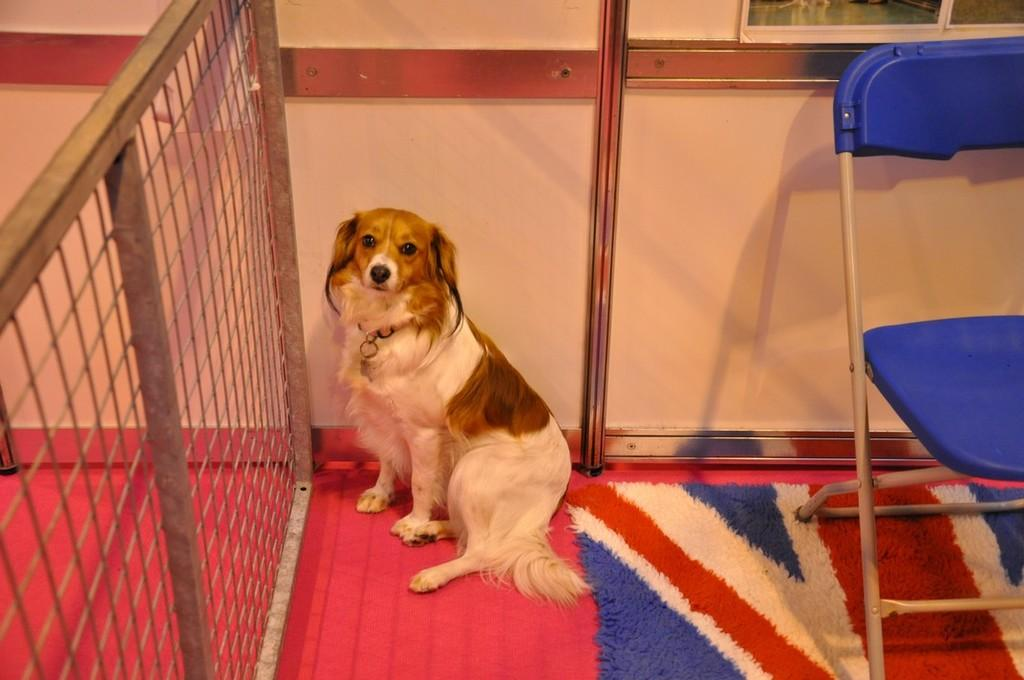What animal is present in the image? There is a dog in the image. Where is the dog sitting? The dog is sitting on a carpet. What can be seen beside the dog? There is a mesh beside the dog. What object is visible on the right side of the image? There is an empty chair on the right side of the image. Who is the volleyball expert sitting on the chair in the image? There is no volleyball expert or chair with a person sitting on it in the image. 